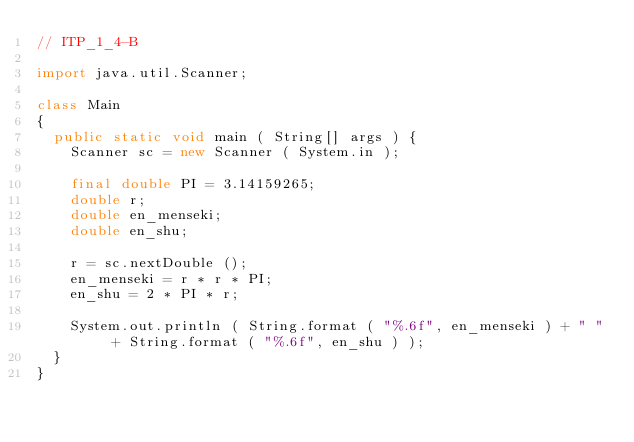Convert code to text. <code><loc_0><loc_0><loc_500><loc_500><_Java_>// ITP_1_4-B

import java.util.Scanner;

class Main
{
	public static void main ( String[] args ) {
		Scanner sc = new Scanner ( System.in );

		final double PI = 3.14159265;
		double r;
		double en_menseki;
		double en_shu;

		r = sc.nextDouble ();
		en_menseki = r * r * PI;
		en_shu = 2 * PI * r;

		System.out.println ( String.format ( "%.6f", en_menseki ) + " " + String.format ( "%.6f", en_shu ) );
	}
}</code> 